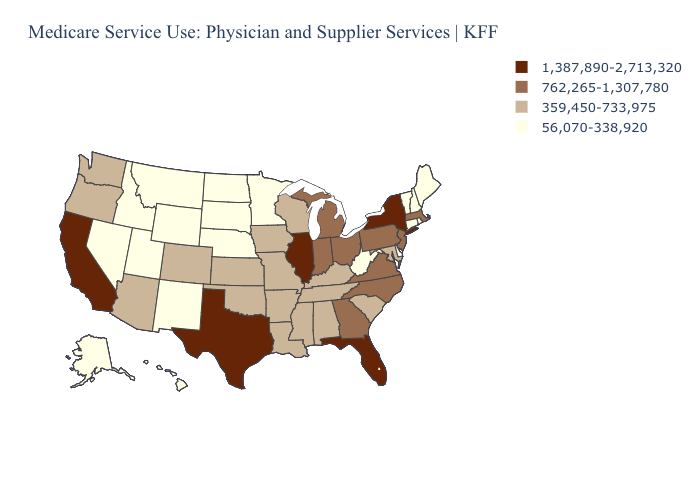What is the highest value in states that border Wisconsin?
Concise answer only. 1,387,890-2,713,320. How many symbols are there in the legend?
Keep it brief. 4. Among the states that border Michigan , does Wisconsin have the lowest value?
Write a very short answer. Yes. What is the lowest value in the USA?
Keep it brief. 56,070-338,920. Name the states that have a value in the range 359,450-733,975?
Quick response, please. Alabama, Arizona, Arkansas, Colorado, Iowa, Kansas, Kentucky, Louisiana, Maryland, Mississippi, Missouri, Oklahoma, Oregon, South Carolina, Tennessee, Washington, Wisconsin. What is the highest value in the MidWest ?
Short answer required. 1,387,890-2,713,320. Does the map have missing data?
Quick response, please. No. Name the states that have a value in the range 359,450-733,975?
Be succinct. Alabama, Arizona, Arkansas, Colorado, Iowa, Kansas, Kentucky, Louisiana, Maryland, Mississippi, Missouri, Oklahoma, Oregon, South Carolina, Tennessee, Washington, Wisconsin. How many symbols are there in the legend?
Write a very short answer. 4. Which states have the highest value in the USA?
Be succinct. California, Florida, Illinois, New York, Texas. What is the value of Colorado?
Keep it brief. 359,450-733,975. What is the highest value in states that border Virginia?
Short answer required. 762,265-1,307,780. Which states have the highest value in the USA?
Answer briefly. California, Florida, Illinois, New York, Texas. What is the value of California?
Be succinct. 1,387,890-2,713,320. What is the value of New Hampshire?
Short answer required. 56,070-338,920. 